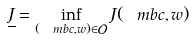Convert formula to latex. <formula><loc_0><loc_0><loc_500><loc_500>\underline { J } = \inf _ { ( \ m b { c } , w ) \in \mathcal { O } } J ( \ m b { c } , w )</formula> 